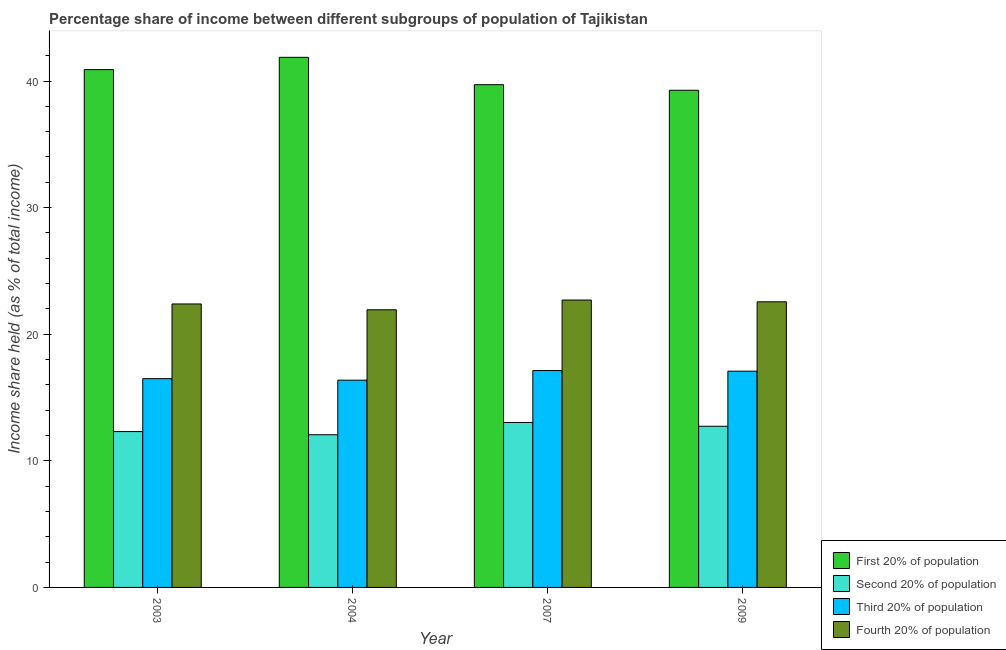How many different coloured bars are there?
Ensure brevity in your answer.  4. How many groups of bars are there?
Your answer should be very brief. 4. What is the share of the income held by first 20% of the population in 2009?
Offer a very short reply. 39.27. Across all years, what is the maximum share of the income held by fourth 20% of the population?
Your answer should be compact. 22.7. Across all years, what is the minimum share of the income held by first 20% of the population?
Provide a succinct answer. 39.27. In which year was the share of the income held by second 20% of the population minimum?
Your answer should be very brief. 2004. What is the total share of the income held by third 20% of the population in the graph?
Provide a succinct answer. 67.07. What is the difference between the share of the income held by second 20% of the population in 2003 and that in 2007?
Ensure brevity in your answer.  -0.72. What is the difference between the share of the income held by second 20% of the population in 2009 and the share of the income held by third 20% of the population in 2003?
Provide a succinct answer. 0.42. What is the average share of the income held by fourth 20% of the population per year?
Provide a succinct answer. 22.39. In the year 2004, what is the difference between the share of the income held by first 20% of the population and share of the income held by fourth 20% of the population?
Provide a succinct answer. 0. In how many years, is the share of the income held by fourth 20% of the population greater than 32 %?
Your answer should be very brief. 0. What is the ratio of the share of the income held by third 20% of the population in 2003 to that in 2007?
Provide a succinct answer. 0.96. Is the share of the income held by fourth 20% of the population in 2007 less than that in 2009?
Ensure brevity in your answer.  No. What is the difference between the highest and the second highest share of the income held by first 20% of the population?
Offer a very short reply. 0.97. What is the difference between the highest and the lowest share of the income held by second 20% of the population?
Your answer should be very brief. 0.97. Is it the case that in every year, the sum of the share of the income held by second 20% of the population and share of the income held by fourth 20% of the population is greater than the sum of share of the income held by third 20% of the population and share of the income held by first 20% of the population?
Your response must be concise. No. What does the 2nd bar from the left in 2004 represents?
Keep it short and to the point. Second 20% of population. What does the 3rd bar from the right in 2003 represents?
Keep it short and to the point. Second 20% of population. Is it the case that in every year, the sum of the share of the income held by first 20% of the population and share of the income held by second 20% of the population is greater than the share of the income held by third 20% of the population?
Provide a succinct answer. Yes. How many bars are there?
Make the answer very short. 16. Where does the legend appear in the graph?
Ensure brevity in your answer.  Bottom right. How are the legend labels stacked?
Your answer should be very brief. Vertical. What is the title of the graph?
Give a very brief answer. Percentage share of income between different subgroups of population of Tajikistan. Does "Bird species" appear as one of the legend labels in the graph?
Give a very brief answer. No. What is the label or title of the Y-axis?
Offer a terse response. Income share held (as % of total income). What is the Income share held (as % of total income) of First 20% of population in 2003?
Provide a succinct answer. 40.9. What is the Income share held (as % of total income) of Second 20% of population in 2003?
Offer a terse response. 12.31. What is the Income share held (as % of total income) in Third 20% of population in 2003?
Offer a very short reply. 16.49. What is the Income share held (as % of total income) in Fourth 20% of population in 2003?
Your answer should be very brief. 22.39. What is the Income share held (as % of total income) in First 20% of population in 2004?
Your answer should be compact. 41.87. What is the Income share held (as % of total income) in Second 20% of population in 2004?
Your answer should be very brief. 12.06. What is the Income share held (as % of total income) of Third 20% of population in 2004?
Offer a very short reply. 16.37. What is the Income share held (as % of total income) of Fourth 20% of population in 2004?
Provide a short and direct response. 21.93. What is the Income share held (as % of total income) of First 20% of population in 2007?
Give a very brief answer. 39.71. What is the Income share held (as % of total income) in Second 20% of population in 2007?
Keep it short and to the point. 13.03. What is the Income share held (as % of total income) of Third 20% of population in 2007?
Provide a short and direct response. 17.13. What is the Income share held (as % of total income) in Fourth 20% of population in 2007?
Give a very brief answer. 22.7. What is the Income share held (as % of total income) of First 20% of population in 2009?
Ensure brevity in your answer.  39.27. What is the Income share held (as % of total income) in Second 20% of population in 2009?
Offer a very short reply. 12.73. What is the Income share held (as % of total income) of Third 20% of population in 2009?
Your answer should be very brief. 17.08. What is the Income share held (as % of total income) in Fourth 20% of population in 2009?
Provide a short and direct response. 22.56. Across all years, what is the maximum Income share held (as % of total income) in First 20% of population?
Provide a short and direct response. 41.87. Across all years, what is the maximum Income share held (as % of total income) in Second 20% of population?
Give a very brief answer. 13.03. Across all years, what is the maximum Income share held (as % of total income) in Third 20% of population?
Provide a short and direct response. 17.13. Across all years, what is the maximum Income share held (as % of total income) in Fourth 20% of population?
Your answer should be compact. 22.7. Across all years, what is the minimum Income share held (as % of total income) in First 20% of population?
Give a very brief answer. 39.27. Across all years, what is the minimum Income share held (as % of total income) in Second 20% of population?
Your answer should be very brief. 12.06. Across all years, what is the minimum Income share held (as % of total income) in Third 20% of population?
Provide a succinct answer. 16.37. Across all years, what is the minimum Income share held (as % of total income) of Fourth 20% of population?
Give a very brief answer. 21.93. What is the total Income share held (as % of total income) of First 20% of population in the graph?
Offer a terse response. 161.75. What is the total Income share held (as % of total income) of Second 20% of population in the graph?
Provide a succinct answer. 50.13. What is the total Income share held (as % of total income) of Third 20% of population in the graph?
Give a very brief answer. 67.07. What is the total Income share held (as % of total income) in Fourth 20% of population in the graph?
Give a very brief answer. 89.58. What is the difference between the Income share held (as % of total income) in First 20% of population in 2003 and that in 2004?
Give a very brief answer. -0.97. What is the difference between the Income share held (as % of total income) in Second 20% of population in 2003 and that in 2004?
Keep it short and to the point. 0.25. What is the difference between the Income share held (as % of total income) in Third 20% of population in 2003 and that in 2004?
Your answer should be very brief. 0.12. What is the difference between the Income share held (as % of total income) of Fourth 20% of population in 2003 and that in 2004?
Your response must be concise. 0.46. What is the difference between the Income share held (as % of total income) of First 20% of population in 2003 and that in 2007?
Ensure brevity in your answer.  1.19. What is the difference between the Income share held (as % of total income) of Second 20% of population in 2003 and that in 2007?
Offer a terse response. -0.72. What is the difference between the Income share held (as % of total income) of Third 20% of population in 2003 and that in 2007?
Provide a succinct answer. -0.64. What is the difference between the Income share held (as % of total income) in Fourth 20% of population in 2003 and that in 2007?
Your answer should be compact. -0.31. What is the difference between the Income share held (as % of total income) in First 20% of population in 2003 and that in 2009?
Give a very brief answer. 1.63. What is the difference between the Income share held (as % of total income) of Second 20% of population in 2003 and that in 2009?
Your answer should be very brief. -0.42. What is the difference between the Income share held (as % of total income) in Third 20% of population in 2003 and that in 2009?
Ensure brevity in your answer.  -0.59. What is the difference between the Income share held (as % of total income) of Fourth 20% of population in 2003 and that in 2009?
Provide a succinct answer. -0.17. What is the difference between the Income share held (as % of total income) of First 20% of population in 2004 and that in 2007?
Give a very brief answer. 2.16. What is the difference between the Income share held (as % of total income) of Second 20% of population in 2004 and that in 2007?
Offer a terse response. -0.97. What is the difference between the Income share held (as % of total income) of Third 20% of population in 2004 and that in 2007?
Your answer should be very brief. -0.76. What is the difference between the Income share held (as % of total income) in Fourth 20% of population in 2004 and that in 2007?
Provide a short and direct response. -0.77. What is the difference between the Income share held (as % of total income) of First 20% of population in 2004 and that in 2009?
Provide a succinct answer. 2.6. What is the difference between the Income share held (as % of total income) of Second 20% of population in 2004 and that in 2009?
Provide a succinct answer. -0.67. What is the difference between the Income share held (as % of total income) of Third 20% of population in 2004 and that in 2009?
Your answer should be compact. -0.71. What is the difference between the Income share held (as % of total income) in Fourth 20% of population in 2004 and that in 2009?
Your answer should be very brief. -0.63. What is the difference between the Income share held (as % of total income) of First 20% of population in 2007 and that in 2009?
Make the answer very short. 0.44. What is the difference between the Income share held (as % of total income) in Second 20% of population in 2007 and that in 2009?
Your response must be concise. 0.3. What is the difference between the Income share held (as % of total income) of Fourth 20% of population in 2007 and that in 2009?
Offer a terse response. 0.14. What is the difference between the Income share held (as % of total income) of First 20% of population in 2003 and the Income share held (as % of total income) of Second 20% of population in 2004?
Your answer should be very brief. 28.84. What is the difference between the Income share held (as % of total income) of First 20% of population in 2003 and the Income share held (as % of total income) of Third 20% of population in 2004?
Offer a terse response. 24.53. What is the difference between the Income share held (as % of total income) in First 20% of population in 2003 and the Income share held (as % of total income) in Fourth 20% of population in 2004?
Make the answer very short. 18.97. What is the difference between the Income share held (as % of total income) in Second 20% of population in 2003 and the Income share held (as % of total income) in Third 20% of population in 2004?
Your answer should be compact. -4.06. What is the difference between the Income share held (as % of total income) of Second 20% of population in 2003 and the Income share held (as % of total income) of Fourth 20% of population in 2004?
Offer a very short reply. -9.62. What is the difference between the Income share held (as % of total income) in Third 20% of population in 2003 and the Income share held (as % of total income) in Fourth 20% of population in 2004?
Give a very brief answer. -5.44. What is the difference between the Income share held (as % of total income) of First 20% of population in 2003 and the Income share held (as % of total income) of Second 20% of population in 2007?
Your response must be concise. 27.87. What is the difference between the Income share held (as % of total income) of First 20% of population in 2003 and the Income share held (as % of total income) of Third 20% of population in 2007?
Ensure brevity in your answer.  23.77. What is the difference between the Income share held (as % of total income) of First 20% of population in 2003 and the Income share held (as % of total income) of Fourth 20% of population in 2007?
Offer a very short reply. 18.2. What is the difference between the Income share held (as % of total income) of Second 20% of population in 2003 and the Income share held (as % of total income) of Third 20% of population in 2007?
Make the answer very short. -4.82. What is the difference between the Income share held (as % of total income) of Second 20% of population in 2003 and the Income share held (as % of total income) of Fourth 20% of population in 2007?
Your response must be concise. -10.39. What is the difference between the Income share held (as % of total income) in Third 20% of population in 2003 and the Income share held (as % of total income) in Fourth 20% of population in 2007?
Offer a terse response. -6.21. What is the difference between the Income share held (as % of total income) of First 20% of population in 2003 and the Income share held (as % of total income) of Second 20% of population in 2009?
Keep it short and to the point. 28.17. What is the difference between the Income share held (as % of total income) in First 20% of population in 2003 and the Income share held (as % of total income) in Third 20% of population in 2009?
Make the answer very short. 23.82. What is the difference between the Income share held (as % of total income) of First 20% of population in 2003 and the Income share held (as % of total income) of Fourth 20% of population in 2009?
Ensure brevity in your answer.  18.34. What is the difference between the Income share held (as % of total income) in Second 20% of population in 2003 and the Income share held (as % of total income) in Third 20% of population in 2009?
Offer a terse response. -4.77. What is the difference between the Income share held (as % of total income) of Second 20% of population in 2003 and the Income share held (as % of total income) of Fourth 20% of population in 2009?
Keep it short and to the point. -10.25. What is the difference between the Income share held (as % of total income) in Third 20% of population in 2003 and the Income share held (as % of total income) in Fourth 20% of population in 2009?
Offer a terse response. -6.07. What is the difference between the Income share held (as % of total income) in First 20% of population in 2004 and the Income share held (as % of total income) in Second 20% of population in 2007?
Make the answer very short. 28.84. What is the difference between the Income share held (as % of total income) of First 20% of population in 2004 and the Income share held (as % of total income) of Third 20% of population in 2007?
Give a very brief answer. 24.74. What is the difference between the Income share held (as % of total income) in First 20% of population in 2004 and the Income share held (as % of total income) in Fourth 20% of population in 2007?
Give a very brief answer. 19.17. What is the difference between the Income share held (as % of total income) in Second 20% of population in 2004 and the Income share held (as % of total income) in Third 20% of population in 2007?
Provide a short and direct response. -5.07. What is the difference between the Income share held (as % of total income) of Second 20% of population in 2004 and the Income share held (as % of total income) of Fourth 20% of population in 2007?
Provide a short and direct response. -10.64. What is the difference between the Income share held (as % of total income) of Third 20% of population in 2004 and the Income share held (as % of total income) of Fourth 20% of population in 2007?
Offer a terse response. -6.33. What is the difference between the Income share held (as % of total income) in First 20% of population in 2004 and the Income share held (as % of total income) in Second 20% of population in 2009?
Give a very brief answer. 29.14. What is the difference between the Income share held (as % of total income) in First 20% of population in 2004 and the Income share held (as % of total income) in Third 20% of population in 2009?
Your response must be concise. 24.79. What is the difference between the Income share held (as % of total income) of First 20% of population in 2004 and the Income share held (as % of total income) of Fourth 20% of population in 2009?
Make the answer very short. 19.31. What is the difference between the Income share held (as % of total income) in Second 20% of population in 2004 and the Income share held (as % of total income) in Third 20% of population in 2009?
Make the answer very short. -5.02. What is the difference between the Income share held (as % of total income) of Third 20% of population in 2004 and the Income share held (as % of total income) of Fourth 20% of population in 2009?
Provide a short and direct response. -6.19. What is the difference between the Income share held (as % of total income) in First 20% of population in 2007 and the Income share held (as % of total income) in Second 20% of population in 2009?
Give a very brief answer. 26.98. What is the difference between the Income share held (as % of total income) in First 20% of population in 2007 and the Income share held (as % of total income) in Third 20% of population in 2009?
Provide a short and direct response. 22.63. What is the difference between the Income share held (as % of total income) of First 20% of population in 2007 and the Income share held (as % of total income) of Fourth 20% of population in 2009?
Your answer should be compact. 17.15. What is the difference between the Income share held (as % of total income) of Second 20% of population in 2007 and the Income share held (as % of total income) of Third 20% of population in 2009?
Give a very brief answer. -4.05. What is the difference between the Income share held (as % of total income) in Second 20% of population in 2007 and the Income share held (as % of total income) in Fourth 20% of population in 2009?
Your response must be concise. -9.53. What is the difference between the Income share held (as % of total income) of Third 20% of population in 2007 and the Income share held (as % of total income) of Fourth 20% of population in 2009?
Your response must be concise. -5.43. What is the average Income share held (as % of total income) of First 20% of population per year?
Provide a succinct answer. 40.44. What is the average Income share held (as % of total income) of Second 20% of population per year?
Make the answer very short. 12.53. What is the average Income share held (as % of total income) in Third 20% of population per year?
Ensure brevity in your answer.  16.77. What is the average Income share held (as % of total income) of Fourth 20% of population per year?
Provide a short and direct response. 22.39. In the year 2003, what is the difference between the Income share held (as % of total income) in First 20% of population and Income share held (as % of total income) in Second 20% of population?
Give a very brief answer. 28.59. In the year 2003, what is the difference between the Income share held (as % of total income) in First 20% of population and Income share held (as % of total income) in Third 20% of population?
Your response must be concise. 24.41. In the year 2003, what is the difference between the Income share held (as % of total income) in First 20% of population and Income share held (as % of total income) in Fourth 20% of population?
Your response must be concise. 18.51. In the year 2003, what is the difference between the Income share held (as % of total income) in Second 20% of population and Income share held (as % of total income) in Third 20% of population?
Your answer should be very brief. -4.18. In the year 2003, what is the difference between the Income share held (as % of total income) in Second 20% of population and Income share held (as % of total income) in Fourth 20% of population?
Your answer should be compact. -10.08. In the year 2004, what is the difference between the Income share held (as % of total income) in First 20% of population and Income share held (as % of total income) in Second 20% of population?
Offer a terse response. 29.81. In the year 2004, what is the difference between the Income share held (as % of total income) in First 20% of population and Income share held (as % of total income) in Fourth 20% of population?
Provide a succinct answer. 19.94. In the year 2004, what is the difference between the Income share held (as % of total income) in Second 20% of population and Income share held (as % of total income) in Third 20% of population?
Offer a very short reply. -4.31. In the year 2004, what is the difference between the Income share held (as % of total income) in Second 20% of population and Income share held (as % of total income) in Fourth 20% of population?
Ensure brevity in your answer.  -9.87. In the year 2004, what is the difference between the Income share held (as % of total income) in Third 20% of population and Income share held (as % of total income) in Fourth 20% of population?
Give a very brief answer. -5.56. In the year 2007, what is the difference between the Income share held (as % of total income) in First 20% of population and Income share held (as % of total income) in Second 20% of population?
Make the answer very short. 26.68. In the year 2007, what is the difference between the Income share held (as % of total income) in First 20% of population and Income share held (as % of total income) in Third 20% of population?
Offer a terse response. 22.58. In the year 2007, what is the difference between the Income share held (as % of total income) of First 20% of population and Income share held (as % of total income) of Fourth 20% of population?
Ensure brevity in your answer.  17.01. In the year 2007, what is the difference between the Income share held (as % of total income) of Second 20% of population and Income share held (as % of total income) of Third 20% of population?
Make the answer very short. -4.1. In the year 2007, what is the difference between the Income share held (as % of total income) of Second 20% of population and Income share held (as % of total income) of Fourth 20% of population?
Offer a very short reply. -9.67. In the year 2007, what is the difference between the Income share held (as % of total income) in Third 20% of population and Income share held (as % of total income) in Fourth 20% of population?
Keep it short and to the point. -5.57. In the year 2009, what is the difference between the Income share held (as % of total income) in First 20% of population and Income share held (as % of total income) in Second 20% of population?
Your response must be concise. 26.54. In the year 2009, what is the difference between the Income share held (as % of total income) in First 20% of population and Income share held (as % of total income) in Third 20% of population?
Provide a short and direct response. 22.19. In the year 2009, what is the difference between the Income share held (as % of total income) of First 20% of population and Income share held (as % of total income) of Fourth 20% of population?
Your answer should be very brief. 16.71. In the year 2009, what is the difference between the Income share held (as % of total income) in Second 20% of population and Income share held (as % of total income) in Third 20% of population?
Provide a short and direct response. -4.35. In the year 2009, what is the difference between the Income share held (as % of total income) of Second 20% of population and Income share held (as % of total income) of Fourth 20% of population?
Your answer should be very brief. -9.83. In the year 2009, what is the difference between the Income share held (as % of total income) in Third 20% of population and Income share held (as % of total income) in Fourth 20% of population?
Offer a very short reply. -5.48. What is the ratio of the Income share held (as % of total income) in First 20% of population in 2003 to that in 2004?
Make the answer very short. 0.98. What is the ratio of the Income share held (as % of total income) of Second 20% of population in 2003 to that in 2004?
Provide a short and direct response. 1.02. What is the ratio of the Income share held (as % of total income) in Third 20% of population in 2003 to that in 2004?
Your response must be concise. 1.01. What is the ratio of the Income share held (as % of total income) of Fourth 20% of population in 2003 to that in 2004?
Provide a succinct answer. 1.02. What is the ratio of the Income share held (as % of total income) in Second 20% of population in 2003 to that in 2007?
Provide a short and direct response. 0.94. What is the ratio of the Income share held (as % of total income) in Third 20% of population in 2003 to that in 2007?
Your answer should be compact. 0.96. What is the ratio of the Income share held (as % of total income) of Fourth 20% of population in 2003 to that in 2007?
Give a very brief answer. 0.99. What is the ratio of the Income share held (as % of total income) of First 20% of population in 2003 to that in 2009?
Your answer should be very brief. 1.04. What is the ratio of the Income share held (as % of total income) of Third 20% of population in 2003 to that in 2009?
Ensure brevity in your answer.  0.97. What is the ratio of the Income share held (as % of total income) of First 20% of population in 2004 to that in 2007?
Your answer should be very brief. 1.05. What is the ratio of the Income share held (as % of total income) of Second 20% of population in 2004 to that in 2007?
Your answer should be compact. 0.93. What is the ratio of the Income share held (as % of total income) in Third 20% of population in 2004 to that in 2007?
Your answer should be very brief. 0.96. What is the ratio of the Income share held (as % of total income) of Fourth 20% of population in 2004 to that in 2007?
Offer a terse response. 0.97. What is the ratio of the Income share held (as % of total income) in First 20% of population in 2004 to that in 2009?
Your answer should be compact. 1.07. What is the ratio of the Income share held (as % of total income) in Third 20% of population in 2004 to that in 2009?
Provide a short and direct response. 0.96. What is the ratio of the Income share held (as % of total income) in Fourth 20% of population in 2004 to that in 2009?
Ensure brevity in your answer.  0.97. What is the ratio of the Income share held (as % of total income) in First 20% of population in 2007 to that in 2009?
Your response must be concise. 1.01. What is the ratio of the Income share held (as % of total income) in Second 20% of population in 2007 to that in 2009?
Make the answer very short. 1.02. What is the difference between the highest and the second highest Income share held (as % of total income) of Fourth 20% of population?
Your answer should be very brief. 0.14. What is the difference between the highest and the lowest Income share held (as % of total income) of First 20% of population?
Offer a terse response. 2.6. What is the difference between the highest and the lowest Income share held (as % of total income) of Third 20% of population?
Your answer should be very brief. 0.76. What is the difference between the highest and the lowest Income share held (as % of total income) of Fourth 20% of population?
Offer a very short reply. 0.77. 